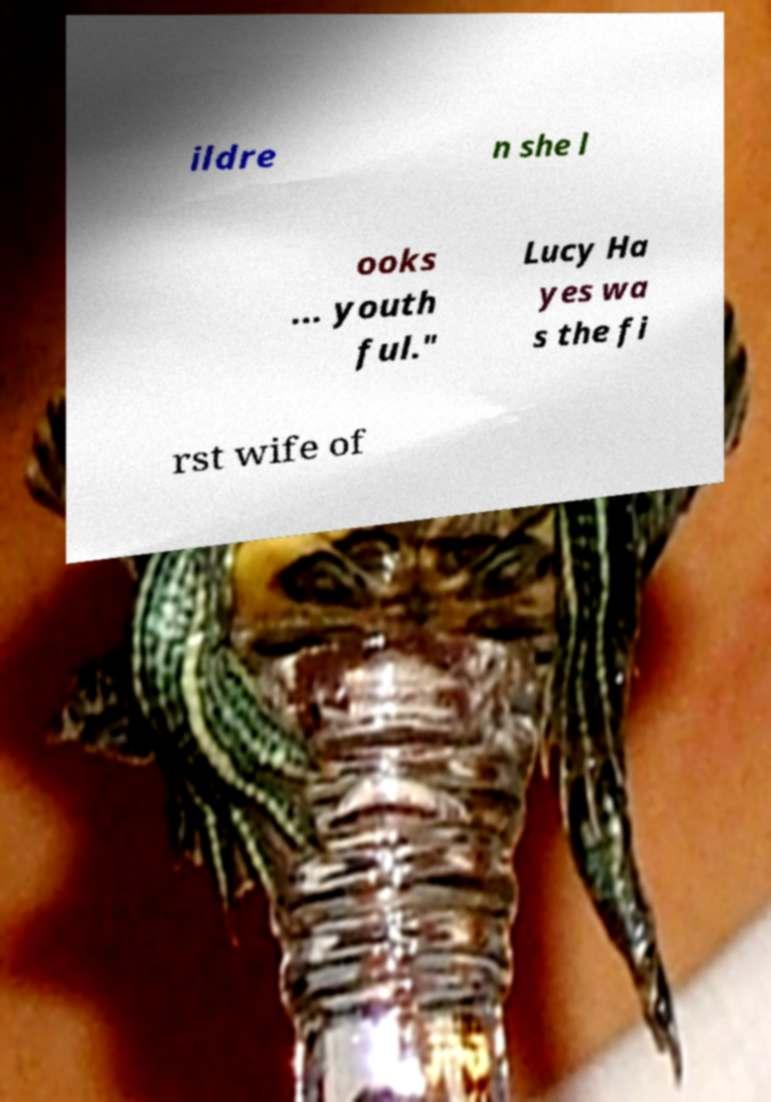I need the written content from this picture converted into text. Can you do that? ildre n she l ooks ... youth ful." Lucy Ha yes wa s the fi rst wife of 